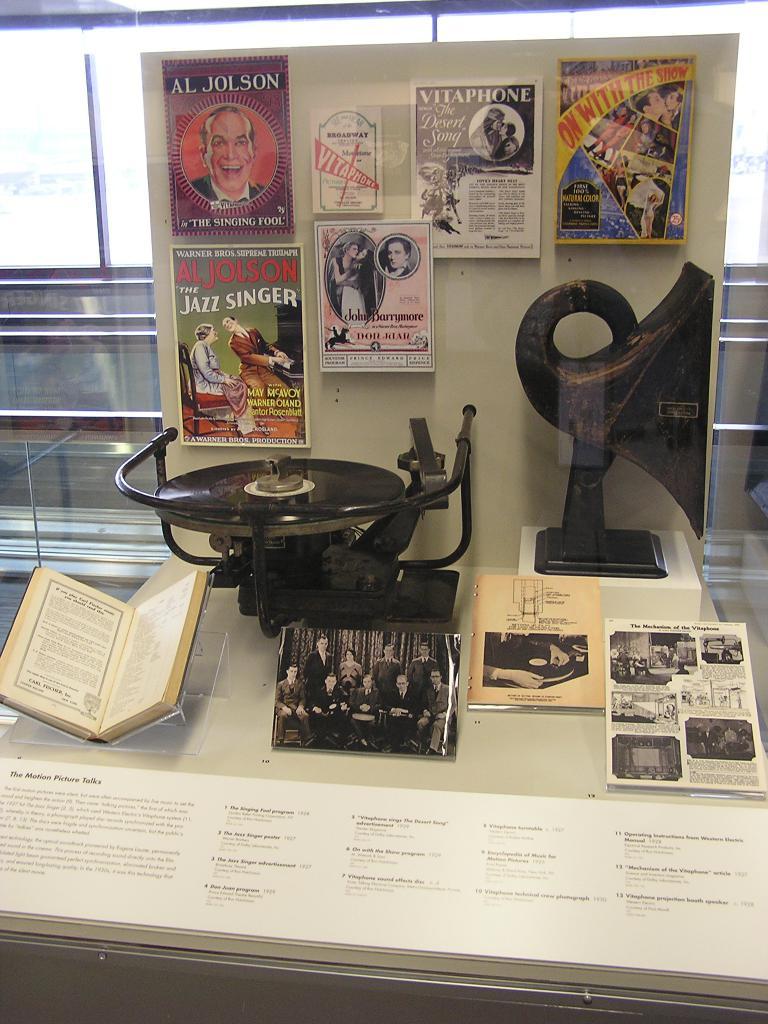What does green sign say?
Provide a short and direct response. The jazz singer. Whos name is written in the very top left picture?
Your response must be concise. Al jolson. 